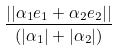<formula> <loc_0><loc_0><loc_500><loc_500>\frac { | | \alpha _ { 1 } e _ { 1 } + \alpha _ { 2 } e _ { 2 } | | } { ( | \alpha _ { 1 } | + | \alpha _ { 2 } | ) }</formula> 